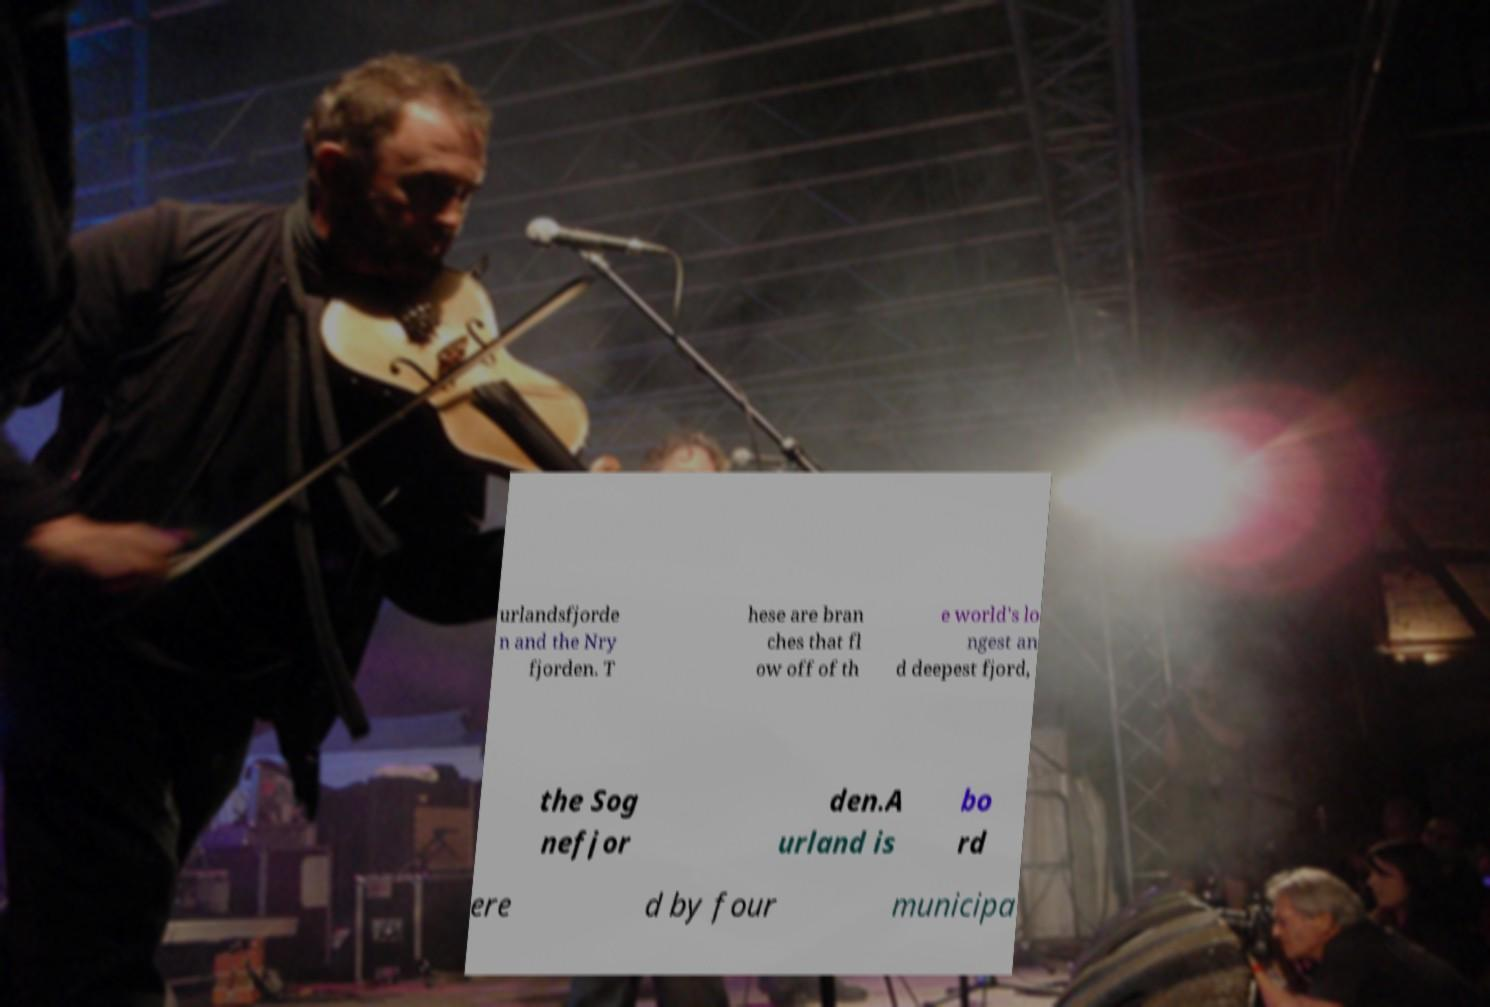Please read and relay the text visible in this image. What does it say? urlandsfjorde n and the Nry fjorden. T hese are bran ches that fl ow off of th e world's lo ngest an d deepest fjord, the Sog nefjor den.A urland is bo rd ere d by four municipa 